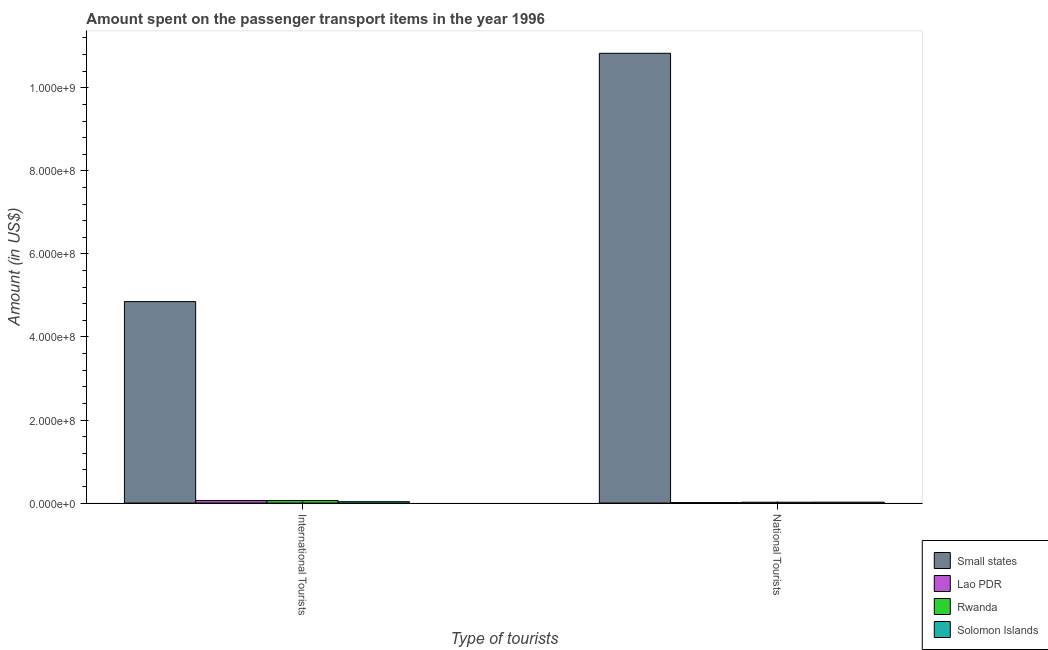How many groups of bars are there?
Make the answer very short. 2. Are the number of bars per tick equal to the number of legend labels?
Ensure brevity in your answer.  Yes. Are the number of bars on each tick of the X-axis equal?
Give a very brief answer. Yes. How many bars are there on the 2nd tick from the left?
Your response must be concise. 4. How many bars are there on the 1st tick from the right?
Your answer should be very brief. 4. What is the label of the 1st group of bars from the left?
Provide a succinct answer. International Tourists. Across all countries, what is the maximum amount spent on transport items of national tourists?
Offer a very short reply. 1.08e+09. In which country was the amount spent on transport items of national tourists maximum?
Offer a terse response. Small states. In which country was the amount spent on transport items of international tourists minimum?
Give a very brief answer. Solomon Islands. What is the total amount spent on transport items of international tourists in the graph?
Provide a succinct answer. 5.01e+08. What is the difference between the amount spent on transport items of international tourists in Solomon Islands and that in Rwanda?
Ensure brevity in your answer.  -2.70e+06. What is the difference between the amount spent on transport items of international tourists in Rwanda and the amount spent on transport items of national tourists in Small states?
Offer a terse response. -1.08e+09. What is the average amount spent on transport items of national tourists per country?
Provide a short and direct response. 2.72e+08. What is the difference between the amount spent on transport items of international tourists and amount spent on transport items of national tourists in Solomon Islands?
Offer a terse response. 1.20e+06. In how many countries, is the amount spent on transport items of international tourists greater than the average amount spent on transport items of international tourists taken over all countries?
Offer a terse response. 1. What does the 4th bar from the left in International Tourists represents?
Your answer should be very brief. Solomon Islands. What does the 3rd bar from the right in National Tourists represents?
Provide a succinct answer. Lao PDR. How many bars are there?
Offer a terse response. 8. Are all the bars in the graph horizontal?
Offer a terse response. No. How many countries are there in the graph?
Provide a short and direct response. 4. What is the difference between two consecutive major ticks on the Y-axis?
Make the answer very short. 2.00e+08. Does the graph contain grids?
Offer a terse response. No. Where does the legend appear in the graph?
Your response must be concise. Bottom right. How are the legend labels stacked?
Offer a terse response. Vertical. What is the title of the graph?
Offer a very short reply. Amount spent on the passenger transport items in the year 1996. What is the label or title of the X-axis?
Keep it short and to the point. Type of tourists. What is the Amount (in US$) in Small states in International Tourists?
Your answer should be very brief. 4.85e+08. What is the Amount (in US$) in Solomon Islands in International Tourists?
Provide a short and direct response. 3.30e+06. What is the Amount (in US$) of Small states in National Tourists?
Offer a terse response. 1.08e+09. What is the Amount (in US$) in Rwanda in National Tourists?
Give a very brief answer. 2.00e+06. What is the Amount (in US$) of Solomon Islands in National Tourists?
Your answer should be compact. 2.10e+06. Across all Type of tourists, what is the maximum Amount (in US$) in Small states?
Provide a short and direct response. 1.08e+09. Across all Type of tourists, what is the maximum Amount (in US$) in Rwanda?
Your answer should be very brief. 6.00e+06. Across all Type of tourists, what is the maximum Amount (in US$) of Solomon Islands?
Your answer should be very brief. 3.30e+06. Across all Type of tourists, what is the minimum Amount (in US$) of Small states?
Offer a terse response. 4.85e+08. Across all Type of tourists, what is the minimum Amount (in US$) of Solomon Islands?
Provide a succinct answer. 2.10e+06. What is the total Amount (in US$) of Small states in the graph?
Your response must be concise. 1.57e+09. What is the total Amount (in US$) in Rwanda in the graph?
Provide a short and direct response. 8.00e+06. What is the total Amount (in US$) of Solomon Islands in the graph?
Your answer should be very brief. 5.40e+06. What is the difference between the Amount (in US$) in Small states in International Tourists and that in National Tourists?
Give a very brief answer. -5.98e+08. What is the difference between the Amount (in US$) in Lao PDR in International Tourists and that in National Tourists?
Offer a very short reply. 5.00e+06. What is the difference between the Amount (in US$) in Solomon Islands in International Tourists and that in National Tourists?
Your answer should be very brief. 1.20e+06. What is the difference between the Amount (in US$) of Small states in International Tourists and the Amount (in US$) of Lao PDR in National Tourists?
Ensure brevity in your answer.  4.84e+08. What is the difference between the Amount (in US$) of Small states in International Tourists and the Amount (in US$) of Rwanda in National Tourists?
Ensure brevity in your answer.  4.83e+08. What is the difference between the Amount (in US$) in Small states in International Tourists and the Amount (in US$) in Solomon Islands in National Tourists?
Your answer should be very brief. 4.83e+08. What is the difference between the Amount (in US$) of Lao PDR in International Tourists and the Amount (in US$) of Solomon Islands in National Tourists?
Provide a succinct answer. 3.90e+06. What is the difference between the Amount (in US$) of Rwanda in International Tourists and the Amount (in US$) of Solomon Islands in National Tourists?
Give a very brief answer. 3.90e+06. What is the average Amount (in US$) in Small states per Type of tourists?
Your response must be concise. 7.84e+08. What is the average Amount (in US$) of Lao PDR per Type of tourists?
Ensure brevity in your answer.  3.50e+06. What is the average Amount (in US$) of Solomon Islands per Type of tourists?
Your answer should be very brief. 2.70e+06. What is the difference between the Amount (in US$) in Small states and Amount (in US$) in Lao PDR in International Tourists?
Your answer should be compact. 4.79e+08. What is the difference between the Amount (in US$) of Small states and Amount (in US$) of Rwanda in International Tourists?
Ensure brevity in your answer.  4.79e+08. What is the difference between the Amount (in US$) of Small states and Amount (in US$) of Solomon Islands in International Tourists?
Provide a succinct answer. 4.82e+08. What is the difference between the Amount (in US$) in Lao PDR and Amount (in US$) in Solomon Islands in International Tourists?
Your answer should be very brief. 2.70e+06. What is the difference between the Amount (in US$) in Rwanda and Amount (in US$) in Solomon Islands in International Tourists?
Provide a short and direct response. 2.70e+06. What is the difference between the Amount (in US$) of Small states and Amount (in US$) of Lao PDR in National Tourists?
Give a very brief answer. 1.08e+09. What is the difference between the Amount (in US$) of Small states and Amount (in US$) of Rwanda in National Tourists?
Your answer should be very brief. 1.08e+09. What is the difference between the Amount (in US$) in Small states and Amount (in US$) in Solomon Islands in National Tourists?
Keep it short and to the point. 1.08e+09. What is the difference between the Amount (in US$) of Lao PDR and Amount (in US$) of Solomon Islands in National Tourists?
Ensure brevity in your answer.  -1.10e+06. What is the ratio of the Amount (in US$) of Small states in International Tourists to that in National Tourists?
Provide a succinct answer. 0.45. What is the ratio of the Amount (in US$) in Lao PDR in International Tourists to that in National Tourists?
Offer a terse response. 6. What is the ratio of the Amount (in US$) in Rwanda in International Tourists to that in National Tourists?
Make the answer very short. 3. What is the ratio of the Amount (in US$) of Solomon Islands in International Tourists to that in National Tourists?
Your answer should be compact. 1.57. What is the difference between the highest and the second highest Amount (in US$) in Small states?
Provide a short and direct response. 5.98e+08. What is the difference between the highest and the second highest Amount (in US$) of Lao PDR?
Provide a short and direct response. 5.00e+06. What is the difference between the highest and the second highest Amount (in US$) of Solomon Islands?
Your answer should be very brief. 1.20e+06. What is the difference between the highest and the lowest Amount (in US$) in Small states?
Keep it short and to the point. 5.98e+08. What is the difference between the highest and the lowest Amount (in US$) of Lao PDR?
Provide a succinct answer. 5.00e+06. What is the difference between the highest and the lowest Amount (in US$) of Solomon Islands?
Your answer should be very brief. 1.20e+06. 